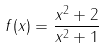<formula> <loc_0><loc_0><loc_500><loc_500>f ( x ) = \frac { x ^ { 2 } + 2 } { x ^ { 2 } + 1 }</formula> 